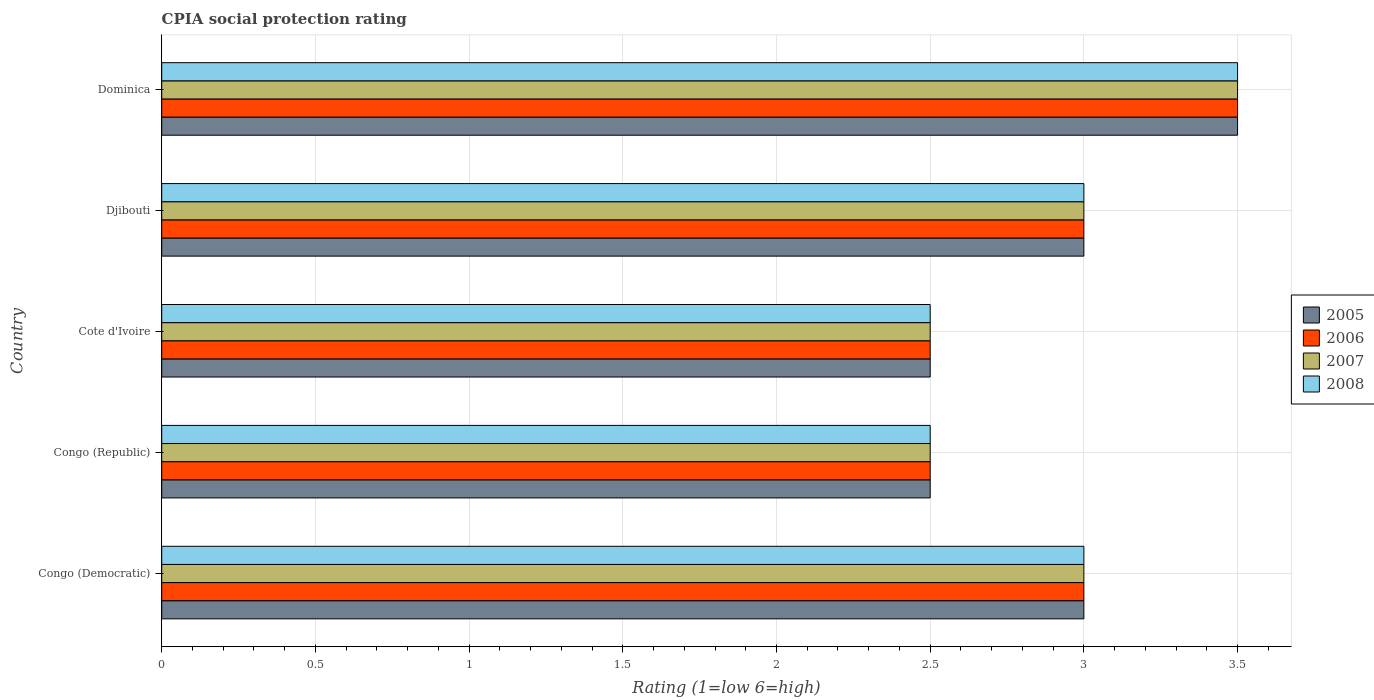How many groups of bars are there?
Offer a terse response. 5. Are the number of bars per tick equal to the number of legend labels?
Your answer should be compact. Yes. Are the number of bars on each tick of the Y-axis equal?
Your response must be concise. Yes. What is the label of the 5th group of bars from the top?
Ensure brevity in your answer.  Congo (Democratic). What is the CPIA rating in 2006 in Djibouti?
Ensure brevity in your answer.  3. Across all countries, what is the minimum CPIA rating in 2007?
Keep it short and to the point. 2.5. In which country was the CPIA rating in 2008 maximum?
Provide a short and direct response. Dominica. In which country was the CPIA rating in 2007 minimum?
Offer a very short reply. Congo (Republic). In how many countries, is the CPIA rating in 2005 greater than 0.5 ?
Ensure brevity in your answer.  5. What is the ratio of the CPIA rating in 2007 in Congo (Democratic) to that in Congo (Republic)?
Your answer should be compact. 1.2. Is the difference between the CPIA rating in 2007 in Congo (Republic) and Djibouti greater than the difference between the CPIA rating in 2008 in Congo (Republic) and Djibouti?
Provide a succinct answer. No. What is the difference between the highest and the second highest CPIA rating in 2005?
Offer a very short reply. 0.5. What is the difference between the highest and the lowest CPIA rating in 2005?
Provide a succinct answer. 1. Is the sum of the CPIA rating in 2007 in Congo (Democratic) and Congo (Republic) greater than the maximum CPIA rating in 2005 across all countries?
Provide a succinct answer. Yes. What does the 4th bar from the bottom in Djibouti represents?
Keep it short and to the point. 2008. Is it the case that in every country, the sum of the CPIA rating in 2007 and CPIA rating in 2005 is greater than the CPIA rating in 2006?
Offer a terse response. Yes. How many bars are there?
Make the answer very short. 20. What is the difference between two consecutive major ticks on the X-axis?
Your response must be concise. 0.5. Are the values on the major ticks of X-axis written in scientific E-notation?
Your response must be concise. No. Where does the legend appear in the graph?
Keep it short and to the point. Center right. How are the legend labels stacked?
Your response must be concise. Vertical. What is the title of the graph?
Provide a short and direct response. CPIA social protection rating. What is the label or title of the X-axis?
Make the answer very short. Rating (1=low 6=high). What is the Rating (1=low 6=high) of 2005 in Congo (Democratic)?
Ensure brevity in your answer.  3. What is the Rating (1=low 6=high) in 2005 in Congo (Republic)?
Provide a succinct answer. 2.5. What is the Rating (1=low 6=high) of 2008 in Congo (Republic)?
Keep it short and to the point. 2.5. What is the Rating (1=low 6=high) of 2005 in Cote d'Ivoire?
Offer a very short reply. 2.5. What is the Rating (1=low 6=high) in 2007 in Cote d'Ivoire?
Provide a succinct answer. 2.5. What is the Rating (1=low 6=high) in 2008 in Djibouti?
Provide a short and direct response. 3. What is the Rating (1=low 6=high) in 2006 in Dominica?
Provide a succinct answer. 3.5. What is the Rating (1=low 6=high) in 2008 in Dominica?
Give a very brief answer. 3.5. Across all countries, what is the minimum Rating (1=low 6=high) in 2005?
Offer a terse response. 2.5. Across all countries, what is the minimum Rating (1=low 6=high) in 2006?
Offer a very short reply. 2.5. Across all countries, what is the minimum Rating (1=low 6=high) in 2008?
Make the answer very short. 2.5. What is the total Rating (1=low 6=high) in 2006 in the graph?
Offer a terse response. 14.5. What is the difference between the Rating (1=low 6=high) of 2007 in Congo (Democratic) and that in Congo (Republic)?
Provide a short and direct response. 0.5. What is the difference between the Rating (1=low 6=high) of 2008 in Congo (Democratic) and that in Cote d'Ivoire?
Your answer should be compact. 0.5. What is the difference between the Rating (1=low 6=high) of 2007 in Congo (Democratic) and that in Djibouti?
Give a very brief answer. 0. What is the difference between the Rating (1=low 6=high) in 2006 in Congo (Republic) and that in Cote d'Ivoire?
Your answer should be very brief. 0. What is the difference between the Rating (1=low 6=high) of 2007 in Congo (Republic) and that in Cote d'Ivoire?
Your response must be concise. 0. What is the difference between the Rating (1=low 6=high) in 2005 in Congo (Republic) and that in Djibouti?
Your answer should be compact. -0.5. What is the difference between the Rating (1=low 6=high) of 2006 in Congo (Republic) and that in Djibouti?
Ensure brevity in your answer.  -0.5. What is the difference between the Rating (1=low 6=high) of 2006 in Congo (Republic) and that in Dominica?
Provide a short and direct response. -1. What is the difference between the Rating (1=low 6=high) in 2007 in Congo (Republic) and that in Dominica?
Give a very brief answer. -1. What is the difference between the Rating (1=low 6=high) of 2005 in Cote d'Ivoire and that in Djibouti?
Offer a terse response. -0.5. What is the difference between the Rating (1=low 6=high) of 2006 in Cote d'Ivoire and that in Djibouti?
Your answer should be very brief. -0.5. What is the difference between the Rating (1=low 6=high) of 2007 in Cote d'Ivoire and that in Dominica?
Provide a short and direct response. -1. What is the difference between the Rating (1=low 6=high) of 2008 in Cote d'Ivoire and that in Dominica?
Give a very brief answer. -1. What is the difference between the Rating (1=low 6=high) in 2005 in Djibouti and that in Dominica?
Offer a terse response. -0.5. What is the difference between the Rating (1=low 6=high) of 2006 in Djibouti and that in Dominica?
Offer a terse response. -0.5. What is the difference between the Rating (1=low 6=high) in 2007 in Djibouti and that in Dominica?
Offer a terse response. -0.5. What is the difference between the Rating (1=low 6=high) in 2005 in Congo (Democratic) and the Rating (1=low 6=high) in 2006 in Congo (Republic)?
Offer a very short reply. 0.5. What is the difference between the Rating (1=low 6=high) in 2005 in Congo (Democratic) and the Rating (1=low 6=high) in 2007 in Congo (Republic)?
Offer a terse response. 0.5. What is the difference between the Rating (1=low 6=high) of 2005 in Congo (Democratic) and the Rating (1=low 6=high) of 2008 in Congo (Republic)?
Ensure brevity in your answer.  0.5. What is the difference between the Rating (1=low 6=high) of 2006 in Congo (Democratic) and the Rating (1=low 6=high) of 2008 in Congo (Republic)?
Your answer should be compact. 0.5. What is the difference between the Rating (1=low 6=high) of 2005 in Congo (Democratic) and the Rating (1=low 6=high) of 2007 in Cote d'Ivoire?
Give a very brief answer. 0.5. What is the difference between the Rating (1=low 6=high) in 2005 in Congo (Democratic) and the Rating (1=low 6=high) in 2008 in Cote d'Ivoire?
Keep it short and to the point. 0.5. What is the difference between the Rating (1=low 6=high) in 2006 in Congo (Democratic) and the Rating (1=low 6=high) in 2008 in Cote d'Ivoire?
Your answer should be compact. 0.5. What is the difference between the Rating (1=low 6=high) in 2007 in Congo (Democratic) and the Rating (1=low 6=high) in 2008 in Cote d'Ivoire?
Your answer should be very brief. 0.5. What is the difference between the Rating (1=low 6=high) of 2005 in Congo (Democratic) and the Rating (1=low 6=high) of 2006 in Djibouti?
Keep it short and to the point. 0. What is the difference between the Rating (1=low 6=high) of 2006 in Congo (Democratic) and the Rating (1=low 6=high) of 2007 in Djibouti?
Your answer should be very brief. 0. What is the difference between the Rating (1=low 6=high) in 2006 in Congo (Democratic) and the Rating (1=low 6=high) in 2008 in Djibouti?
Offer a terse response. 0. What is the difference between the Rating (1=low 6=high) in 2005 in Congo (Democratic) and the Rating (1=low 6=high) in 2006 in Dominica?
Give a very brief answer. -0.5. What is the difference between the Rating (1=low 6=high) in 2005 in Congo (Democratic) and the Rating (1=low 6=high) in 2007 in Dominica?
Your answer should be compact. -0.5. What is the difference between the Rating (1=low 6=high) of 2006 in Congo (Democratic) and the Rating (1=low 6=high) of 2007 in Dominica?
Your response must be concise. -0.5. What is the difference between the Rating (1=low 6=high) of 2006 in Congo (Republic) and the Rating (1=low 6=high) of 2007 in Cote d'Ivoire?
Give a very brief answer. 0. What is the difference between the Rating (1=low 6=high) of 2006 in Congo (Republic) and the Rating (1=low 6=high) of 2008 in Cote d'Ivoire?
Offer a terse response. 0. What is the difference between the Rating (1=low 6=high) in 2005 in Congo (Republic) and the Rating (1=low 6=high) in 2006 in Djibouti?
Make the answer very short. -0.5. What is the difference between the Rating (1=low 6=high) of 2006 in Congo (Republic) and the Rating (1=low 6=high) of 2007 in Djibouti?
Your answer should be very brief. -0.5. What is the difference between the Rating (1=low 6=high) of 2006 in Congo (Republic) and the Rating (1=low 6=high) of 2008 in Djibouti?
Make the answer very short. -0.5. What is the difference between the Rating (1=low 6=high) of 2007 in Congo (Republic) and the Rating (1=low 6=high) of 2008 in Djibouti?
Offer a terse response. -0.5. What is the difference between the Rating (1=low 6=high) in 2005 in Congo (Republic) and the Rating (1=low 6=high) in 2007 in Dominica?
Make the answer very short. -1. What is the difference between the Rating (1=low 6=high) in 2005 in Congo (Republic) and the Rating (1=low 6=high) in 2008 in Dominica?
Your answer should be compact. -1. What is the difference between the Rating (1=low 6=high) of 2007 in Congo (Republic) and the Rating (1=low 6=high) of 2008 in Dominica?
Your answer should be compact. -1. What is the difference between the Rating (1=low 6=high) of 2005 in Cote d'Ivoire and the Rating (1=low 6=high) of 2006 in Djibouti?
Ensure brevity in your answer.  -0.5. What is the difference between the Rating (1=low 6=high) in 2005 in Cote d'Ivoire and the Rating (1=low 6=high) in 2007 in Djibouti?
Make the answer very short. -0.5. What is the difference between the Rating (1=low 6=high) in 2006 in Djibouti and the Rating (1=low 6=high) in 2007 in Dominica?
Offer a very short reply. -0.5. What is the difference between the Rating (1=low 6=high) of 2006 in Djibouti and the Rating (1=low 6=high) of 2008 in Dominica?
Keep it short and to the point. -0.5. What is the average Rating (1=low 6=high) in 2005 per country?
Your response must be concise. 2.9. What is the difference between the Rating (1=low 6=high) in 2005 and Rating (1=low 6=high) in 2006 in Congo (Democratic)?
Offer a very short reply. 0. What is the difference between the Rating (1=low 6=high) of 2005 and Rating (1=low 6=high) of 2007 in Congo (Democratic)?
Make the answer very short. 0. What is the difference between the Rating (1=low 6=high) in 2005 and Rating (1=low 6=high) in 2008 in Congo (Democratic)?
Keep it short and to the point. 0. What is the difference between the Rating (1=low 6=high) in 2006 and Rating (1=low 6=high) in 2008 in Congo (Democratic)?
Provide a succinct answer. 0. What is the difference between the Rating (1=low 6=high) in 2005 and Rating (1=low 6=high) in 2006 in Congo (Republic)?
Ensure brevity in your answer.  0. What is the difference between the Rating (1=low 6=high) of 2005 and Rating (1=low 6=high) of 2007 in Congo (Republic)?
Your response must be concise. 0. What is the difference between the Rating (1=low 6=high) in 2007 and Rating (1=low 6=high) in 2008 in Congo (Republic)?
Keep it short and to the point. 0. What is the difference between the Rating (1=low 6=high) of 2005 and Rating (1=low 6=high) of 2006 in Cote d'Ivoire?
Make the answer very short. 0. What is the difference between the Rating (1=low 6=high) in 2005 and Rating (1=low 6=high) in 2007 in Cote d'Ivoire?
Your answer should be compact. 0. What is the difference between the Rating (1=low 6=high) in 2005 and Rating (1=low 6=high) in 2008 in Cote d'Ivoire?
Offer a very short reply. 0. What is the difference between the Rating (1=low 6=high) in 2006 and Rating (1=low 6=high) in 2007 in Cote d'Ivoire?
Ensure brevity in your answer.  0. What is the difference between the Rating (1=low 6=high) of 2005 and Rating (1=low 6=high) of 2007 in Djibouti?
Your answer should be compact. 0. What is the difference between the Rating (1=low 6=high) of 2005 and Rating (1=low 6=high) of 2008 in Djibouti?
Provide a succinct answer. 0. What is the difference between the Rating (1=low 6=high) in 2006 and Rating (1=low 6=high) in 2007 in Djibouti?
Offer a terse response. 0. What is the difference between the Rating (1=low 6=high) of 2006 and Rating (1=low 6=high) of 2008 in Djibouti?
Make the answer very short. 0. What is the difference between the Rating (1=low 6=high) of 2007 and Rating (1=low 6=high) of 2008 in Djibouti?
Keep it short and to the point. 0. What is the difference between the Rating (1=low 6=high) of 2005 and Rating (1=low 6=high) of 2006 in Dominica?
Your answer should be compact. 0. What is the difference between the Rating (1=low 6=high) of 2006 and Rating (1=low 6=high) of 2007 in Dominica?
Your answer should be compact. 0. What is the ratio of the Rating (1=low 6=high) of 2006 in Congo (Democratic) to that in Congo (Republic)?
Ensure brevity in your answer.  1.2. What is the ratio of the Rating (1=low 6=high) in 2005 in Congo (Democratic) to that in Cote d'Ivoire?
Offer a terse response. 1.2. What is the ratio of the Rating (1=low 6=high) in 2006 in Congo (Democratic) to that in Cote d'Ivoire?
Offer a terse response. 1.2. What is the ratio of the Rating (1=low 6=high) of 2005 in Congo (Democratic) to that in Djibouti?
Ensure brevity in your answer.  1. What is the ratio of the Rating (1=low 6=high) of 2008 in Congo (Democratic) to that in Djibouti?
Your answer should be very brief. 1. What is the ratio of the Rating (1=low 6=high) of 2006 in Congo (Democratic) to that in Dominica?
Provide a short and direct response. 0.86. What is the ratio of the Rating (1=low 6=high) in 2007 in Congo (Democratic) to that in Dominica?
Your answer should be very brief. 0.86. What is the ratio of the Rating (1=low 6=high) of 2008 in Congo (Democratic) to that in Dominica?
Provide a succinct answer. 0.86. What is the ratio of the Rating (1=low 6=high) in 2005 in Congo (Republic) to that in Cote d'Ivoire?
Your answer should be very brief. 1. What is the ratio of the Rating (1=low 6=high) in 2006 in Congo (Republic) to that in Cote d'Ivoire?
Your answer should be compact. 1. What is the ratio of the Rating (1=low 6=high) of 2008 in Congo (Republic) to that in Cote d'Ivoire?
Keep it short and to the point. 1. What is the ratio of the Rating (1=low 6=high) of 2005 in Congo (Republic) to that in Djibouti?
Give a very brief answer. 0.83. What is the ratio of the Rating (1=low 6=high) of 2006 in Congo (Republic) to that in Djibouti?
Give a very brief answer. 0.83. What is the ratio of the Rating (1=low 6=high) of 2007 in Congo (Republic) to that in Djibouti?
Your response must be concise. 0.83. What is the ratio of the Rating (1=low 6=high) of 2008 in Congo (Republic) to that in Djibouti?
Offer a very short reply. 0.83. What is the ratio of the Rating (1=low 6=high) in 2005 in Congo (Republic) to that in Dominica?
Offer a terse response. 0.71. What is the ratio of the Rating (1=low 6=high) in 2006 in Congo (Republic) to that in Dominica?
Your answer should be compact. 0.71. What is the ratio of the Rating (1=low 6=high) of 2007 in Congo (Republic) to that in Dominica?
Keep it short and to the point. 0.71. What is the ratio of the Rating (1=low 6=high) in 2006 in Cote d'Ivoire to that in Djibouti?
Your answer should be very brief. 0.83. What is the ratio of the Rating (1=low 6=high) in 2008 in Cote d'Ivoire to that in Djibouti?
Keep it short and to the point. 0.83. What is the ratio of the Rating (1=low 6=high) of 2005 in Cote d'Ivoire to that in Dominica?
Your answer should be compact. 0.71. What is the ratio of the Rating (1=low 6=high) in 2007 in Cote d'Ivoire to that in Dominica?
Offer a terse response. 0.71. What is the ratio of the Rating (1=low 6=high) in 2006 in Djibouti to that in Dominica?
Make the answer very short. 0.86. What is the ratio of the Rating (1=low 6=high) of 2007 in Djibouti to that in Dominica?
Give a very brief answer. 0.86. What is the difference between the highest and the second highest Rating (1=low 6=high) of 2007?
Offer a very short reply. 0.5. What is the difference between the highest and the second highest Rating (1=low 6=high) in 2008?
Give a very brief answer. 0.5. What is the difference between the highest and the lowest Rating (1=low 6=high) in 2006?
Provide a short and direct response. 1. What is the difference between the highest and the lowest Rating (1=low 6=high) in 2008?
Your answer should be compact. 1. 